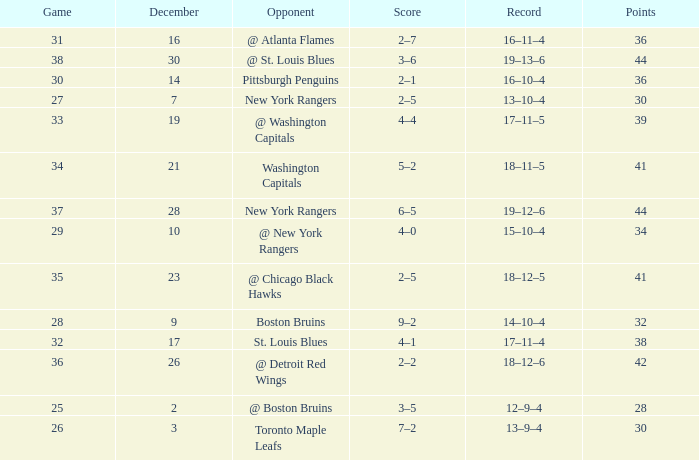Which Score has a Game larger than 32, and Points smaller than 42, and a December larger than 19, and a Record of 18–12–5? 2–5. 